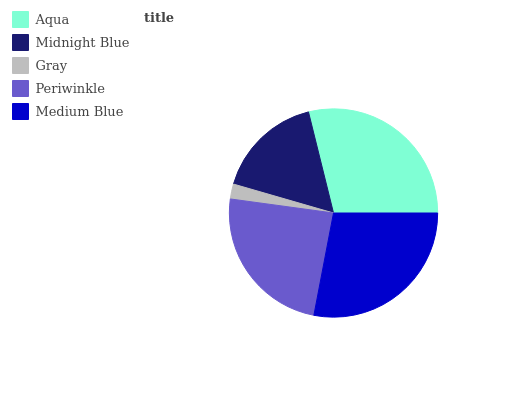Is Gray the minimum?
Answer yes or no. Yes. Is Aqua the maximum?
Answer yes or no. Yes. Is Midnight Blue the minimum?
Answer yes or no. No. Is Midnight Blue the maximum?
Answer yes or no. No. Is Aqua greater than Midnight Blue?
Answer yes or no. Yes. Is Midnight Blue less than Aqua?
Answer yes or no. Yes. Is Midnight Blue greater than Aqua?
Answer yes or no. No. Is Aqua less than Midnight Blue?
Answer yes or no. No. Is Periwinkle the high median?
Answer yes or no. Yes. Is Periwinkle the low median?
Answer yes or no. Yes. Is Midnight Blue the high median?
Answer yes or no. No. Is Medium Blue the low median?
Answer yes or no. No. 